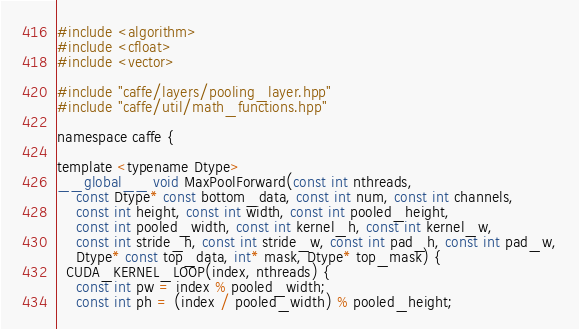<code> <loc_0><loc_0><loc_500><loc_500><_Cuda_>#include <algorithm>
#include <cfloat>
#include <vector>

#include "caffe/layers/pooling_layer.hpp"
#include "caffe/util/math_functions.hpp"

namespace caffe {

template <typename Dtype>
__global__ void MaxPoolForward(const int nthreads,
    const Dtype* const bottom_data, const int num, const int channels,
    const int height, const int width, const int pooled_height,
    const int pooled_width, const int kernel_h, const int kernel_w,
    const int stride_h, const int stride_w, const int pad_h, const int pad_w,
    Dtype* const top_data, int* mask, Dtype* top_mask) {
  CUDA_KERNEL_LOOP(index, nthreads) {
    const int pw = index % pooled_width;
    const int ph = (index / pooled_width) % pooled_height;</code> 